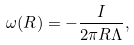<formula> <loc_0><loc_0><loc_500><loc_500>\omega ( R ) = - \frac { I } { 2 \pi R \Lambda } ,</formula> 